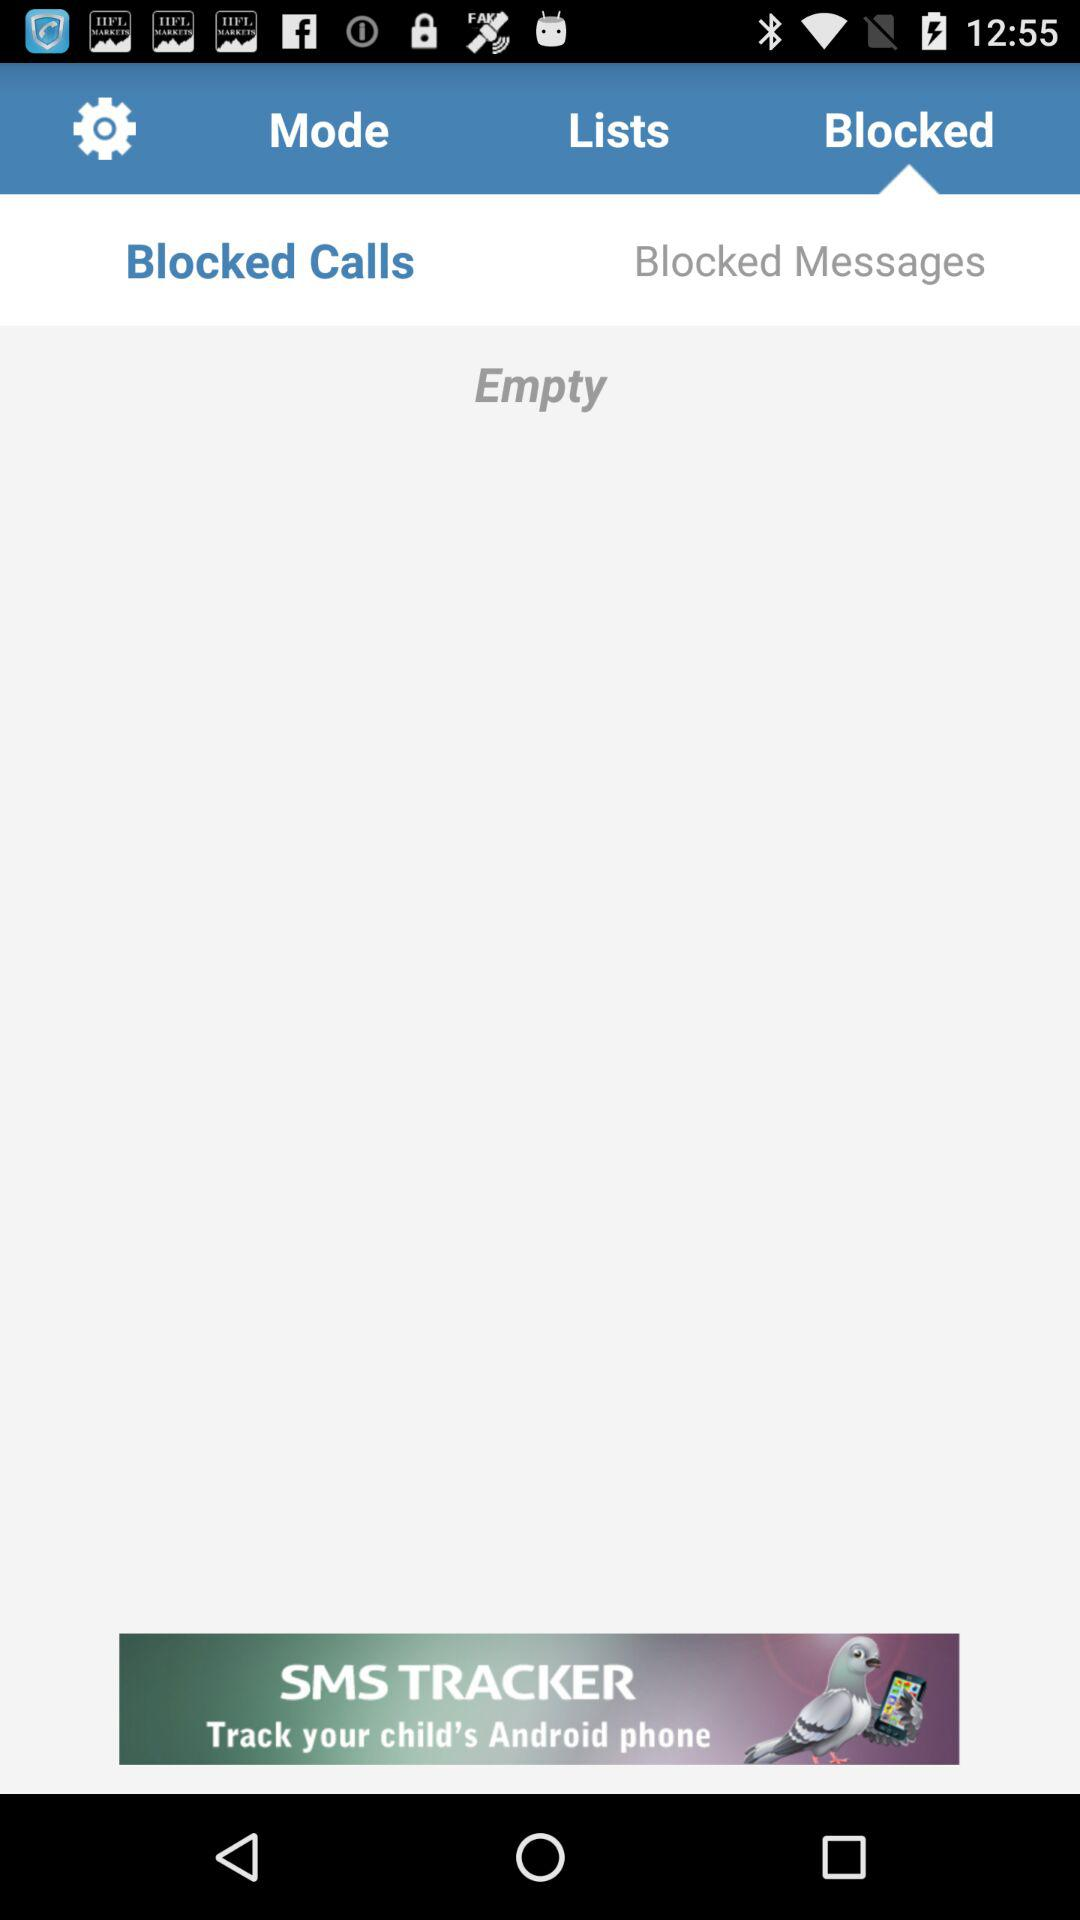Which tab am I on? You are on the "Blocked" tab. 